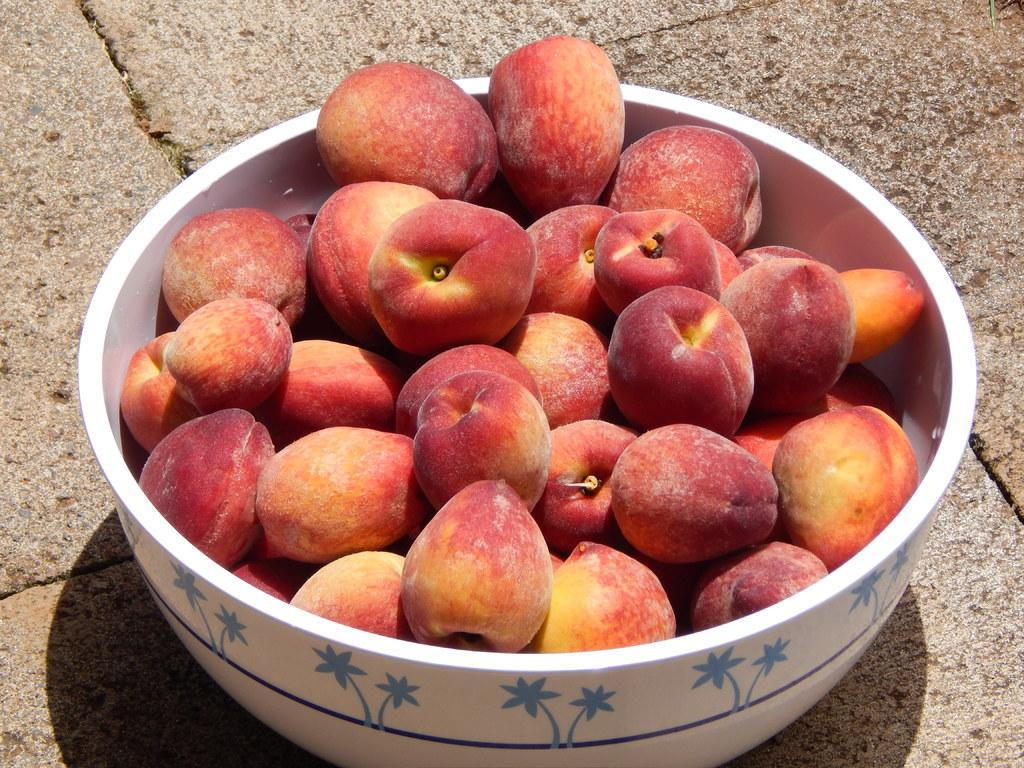What color is the bowl in the image? The bowl in the image is white. What type of fruit is in the bowl? There are red color apples in the bowl. What page number is the birthday celebration taking place on in the image? There is no mention of a birthday celebration or a page in the image; it only features a white bowl with red apples. 